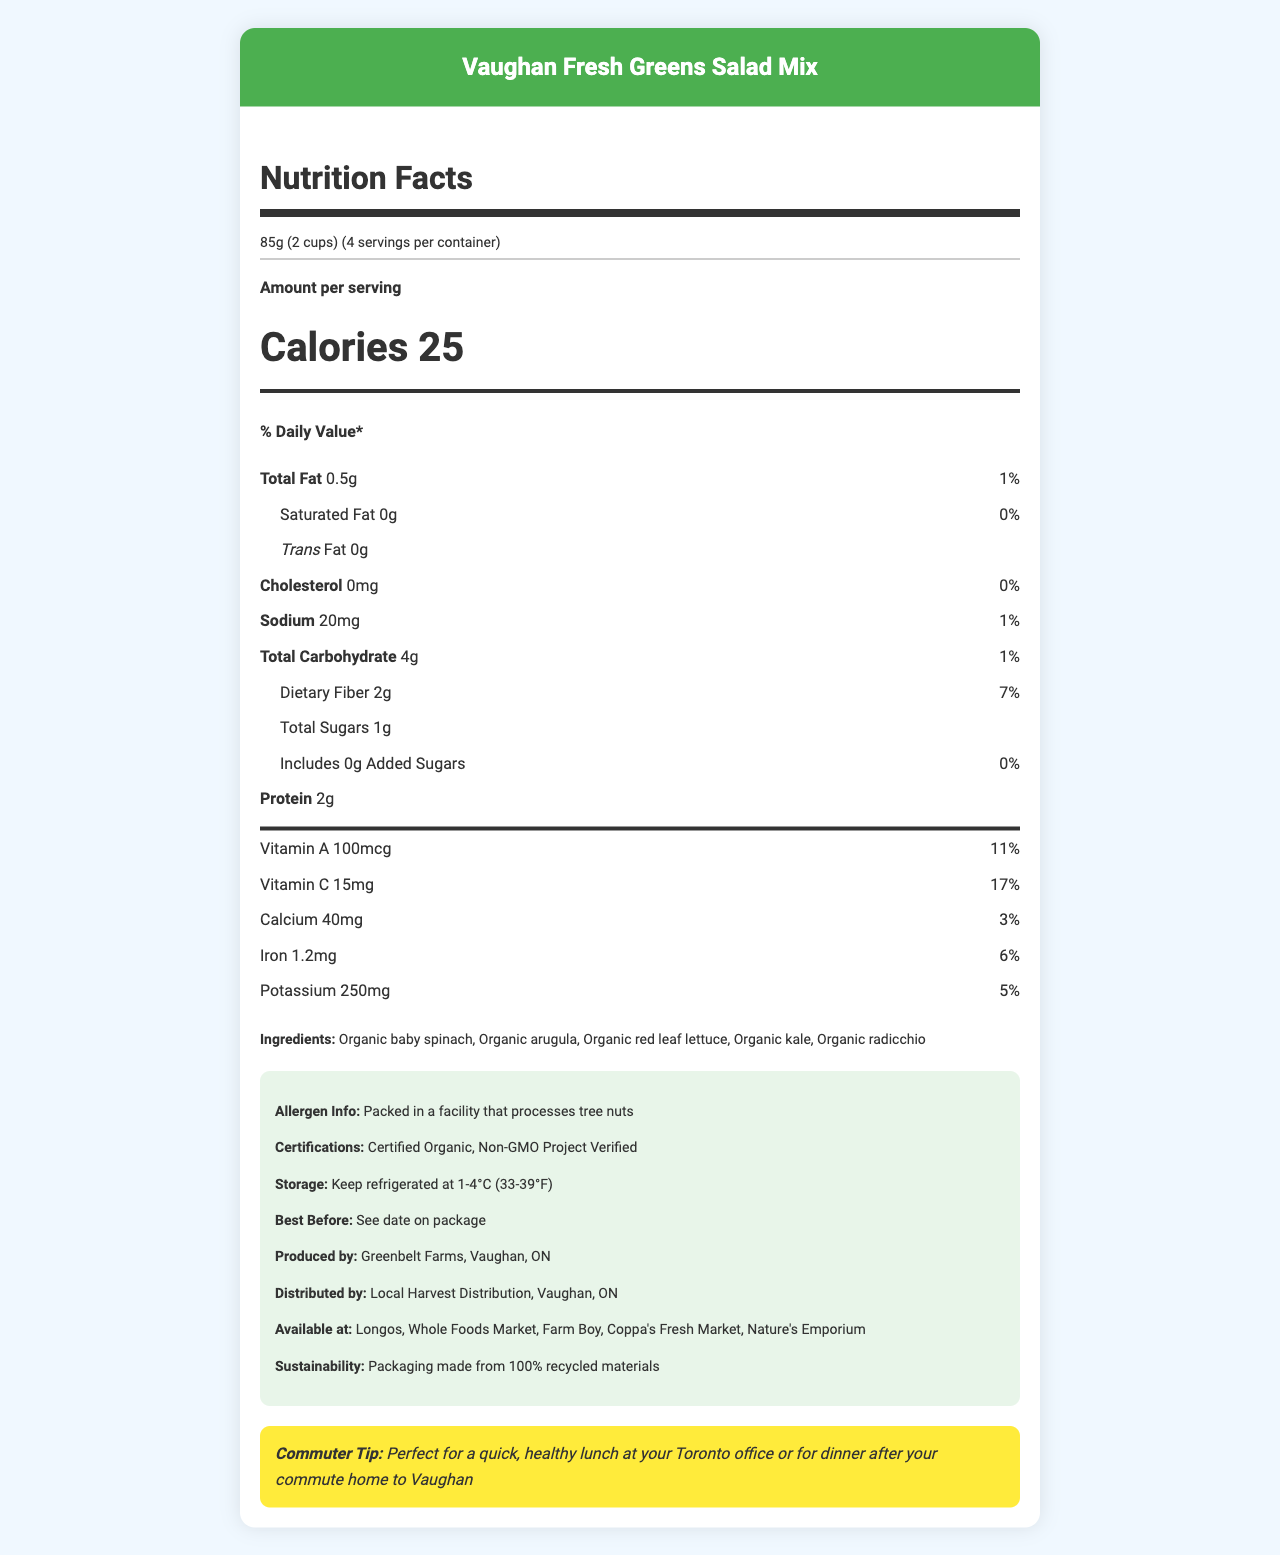what is the serving size? The serving size is clearly stated at the top of the document under the "serving info" section.
Answer: 85g (2 cups) how many calories are there per serving? The number of calories per serving is prominently displayed in a large font in the nutrition facts section.
Answer: 25 how many servings are in a container? The document mentions that there are 4 servings per container right next to the serving size.
Answer: 4 what is the percentage daily value of dietary fiber per serving? The percentage daily value of dietary fiber is listed in the nutrition facts section next to the amount of dietary fiber.
Answer: 7% which vitamin has a higher daily value percentage per serving, Vitamin A or Vitamin C? Vitamin A has an 11% daily value per serving, while Vitamin C has a 17% daily value per serving, as indicated in the nutrition facts section.
Answer: Vitamin C what is the sodium content per serving? The sodium content per serving is listed as 20mg in the nutrition facts section.
Answer: 20mg which ingredient is not included in the salad mix? A. Organic kale B. Organic spinach C. Organic cucumbers D. Organic radicchio The list of ingredients includes Organic baby spinach, Organic arugula, Organic red leaf lettuce, Organic kale, and Organic radicchio; Organic cucumbers are not listed.
Answer: C. Organic cucumbers where is the salad mix produced? A. Toronto, ON B. Vaughan, ON C. Brampton, ON D. Mississauga, ON The document states that the salad mix is produced by Greenbelt Farms in Vaughan, ON.
Answer: B. Vaughan, ON is the salad mix certified organic? The document mentions that the salad mix is Certified Organic in the additional information section.
Answer: Yes summarize the main idea of the document. The document covers various aspects such as nutrition facts, ingredients, allergen info, certifications, sustainability, and availability locations. It further emphasizes the product's local origins and benefits for Vaughan commuters.
Answer: The document provides detailed nutrition facts, ingredient information, allergen information, storage instructions, and certifications for the Vaughan Fresh Greens Salad Mix. It highlights that the product is locally sourced from Vaughan, ON, and contains healthy ingredients, making it suitable for a quick lunch or dinner. what is the expiration date of the salad mix? The document only states "See date on package" for the best before date, so we cannot determine the exact expiration date from the given information.
Answer: Cannot be determined 